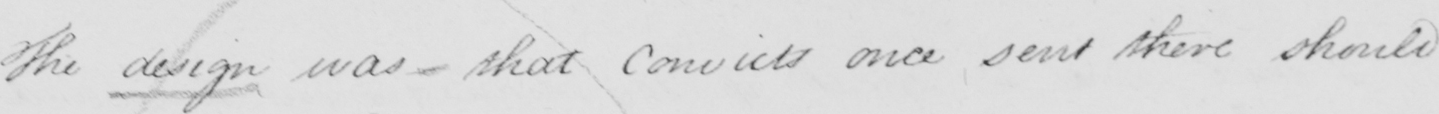What does this handwritten line say? The design was _ that Convicts once sent there should 